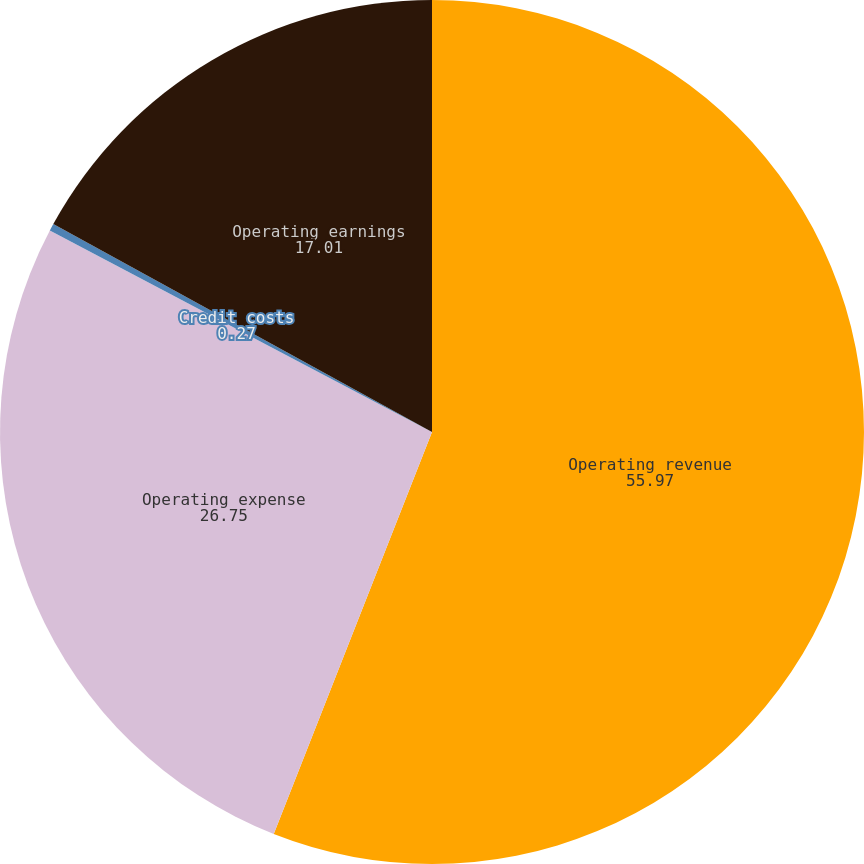Convert chart to OTSL. <chart><loc_0><loc_0><loc_500><loc_500><pie_chart><fcel>Operating revenue<fcel>Operating expense<fcel>Credit costs<fcel>Operating earnings<nl><fcel>55.97%<fcel>26.75%<fcel>0.27%<fcel>17.01%<nl></chart> 